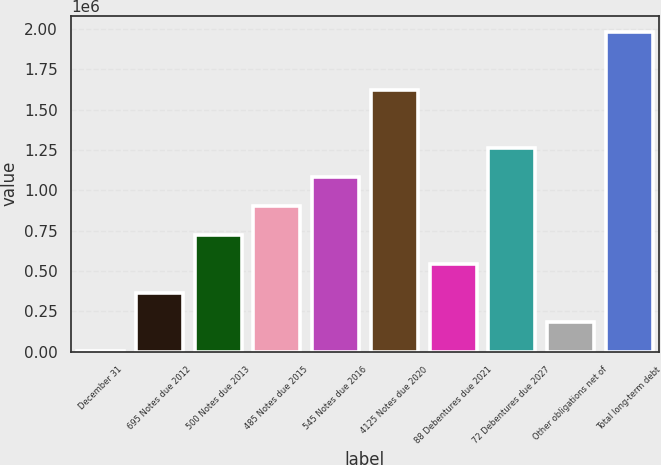Convert chart to OTSL. <chart><loc_0><loc_0><loc_500><loc_500><bar_chart><fcel>December 31<fcel>695 Notes due 2012<fcel>500 Notes due 2013<fcel>485 Notes due 2015<fcel>545 Notes due 2016<fcel>4125 Notes due 2020<fcel>88 Debentures due 2021<fcel>72 Debentures due 2027<fcel>Other obligations net of<fcel>Total long-term debt<nl><fcel>2010<fcel>362251<fcel>722493<fcel>902614<fcel>1.08273e+06<fcel>1.6231e+06<fcel>542372<fcel>1.26285e+06<fcel>182131<fcel>1.98334e+06<nl></chart> 